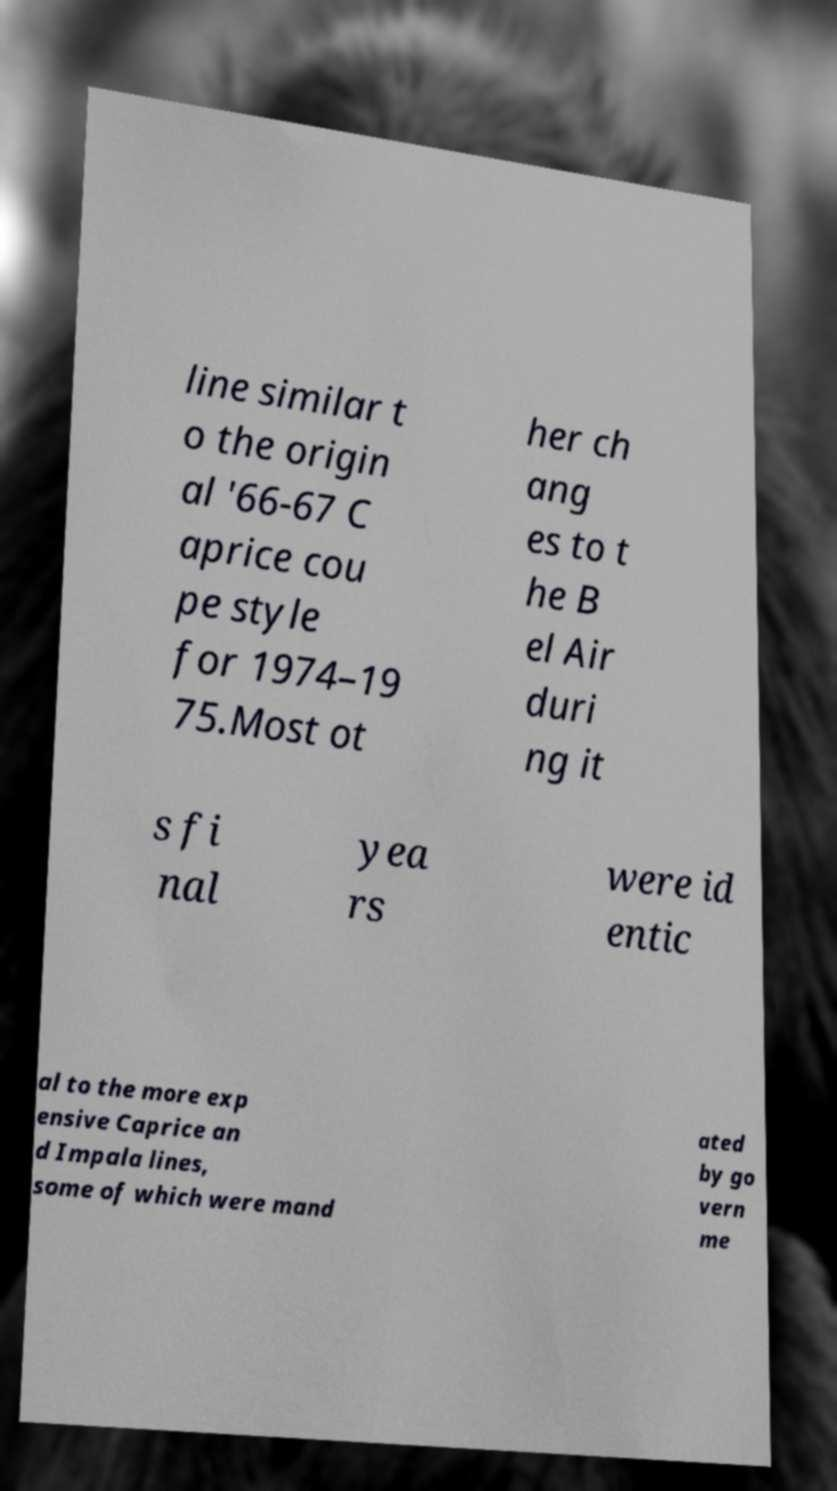Could you extract and type out the text from this image? line similar t o the origin al '66-67 C aprice cou pe style for 1974–19 75.Most ot her ch ang es to t he B el Air duri ng it s fi nal yea rs were id entic al to the more exp ensive Caprice an d Impala lines, some of which were mand ated by go vern me 